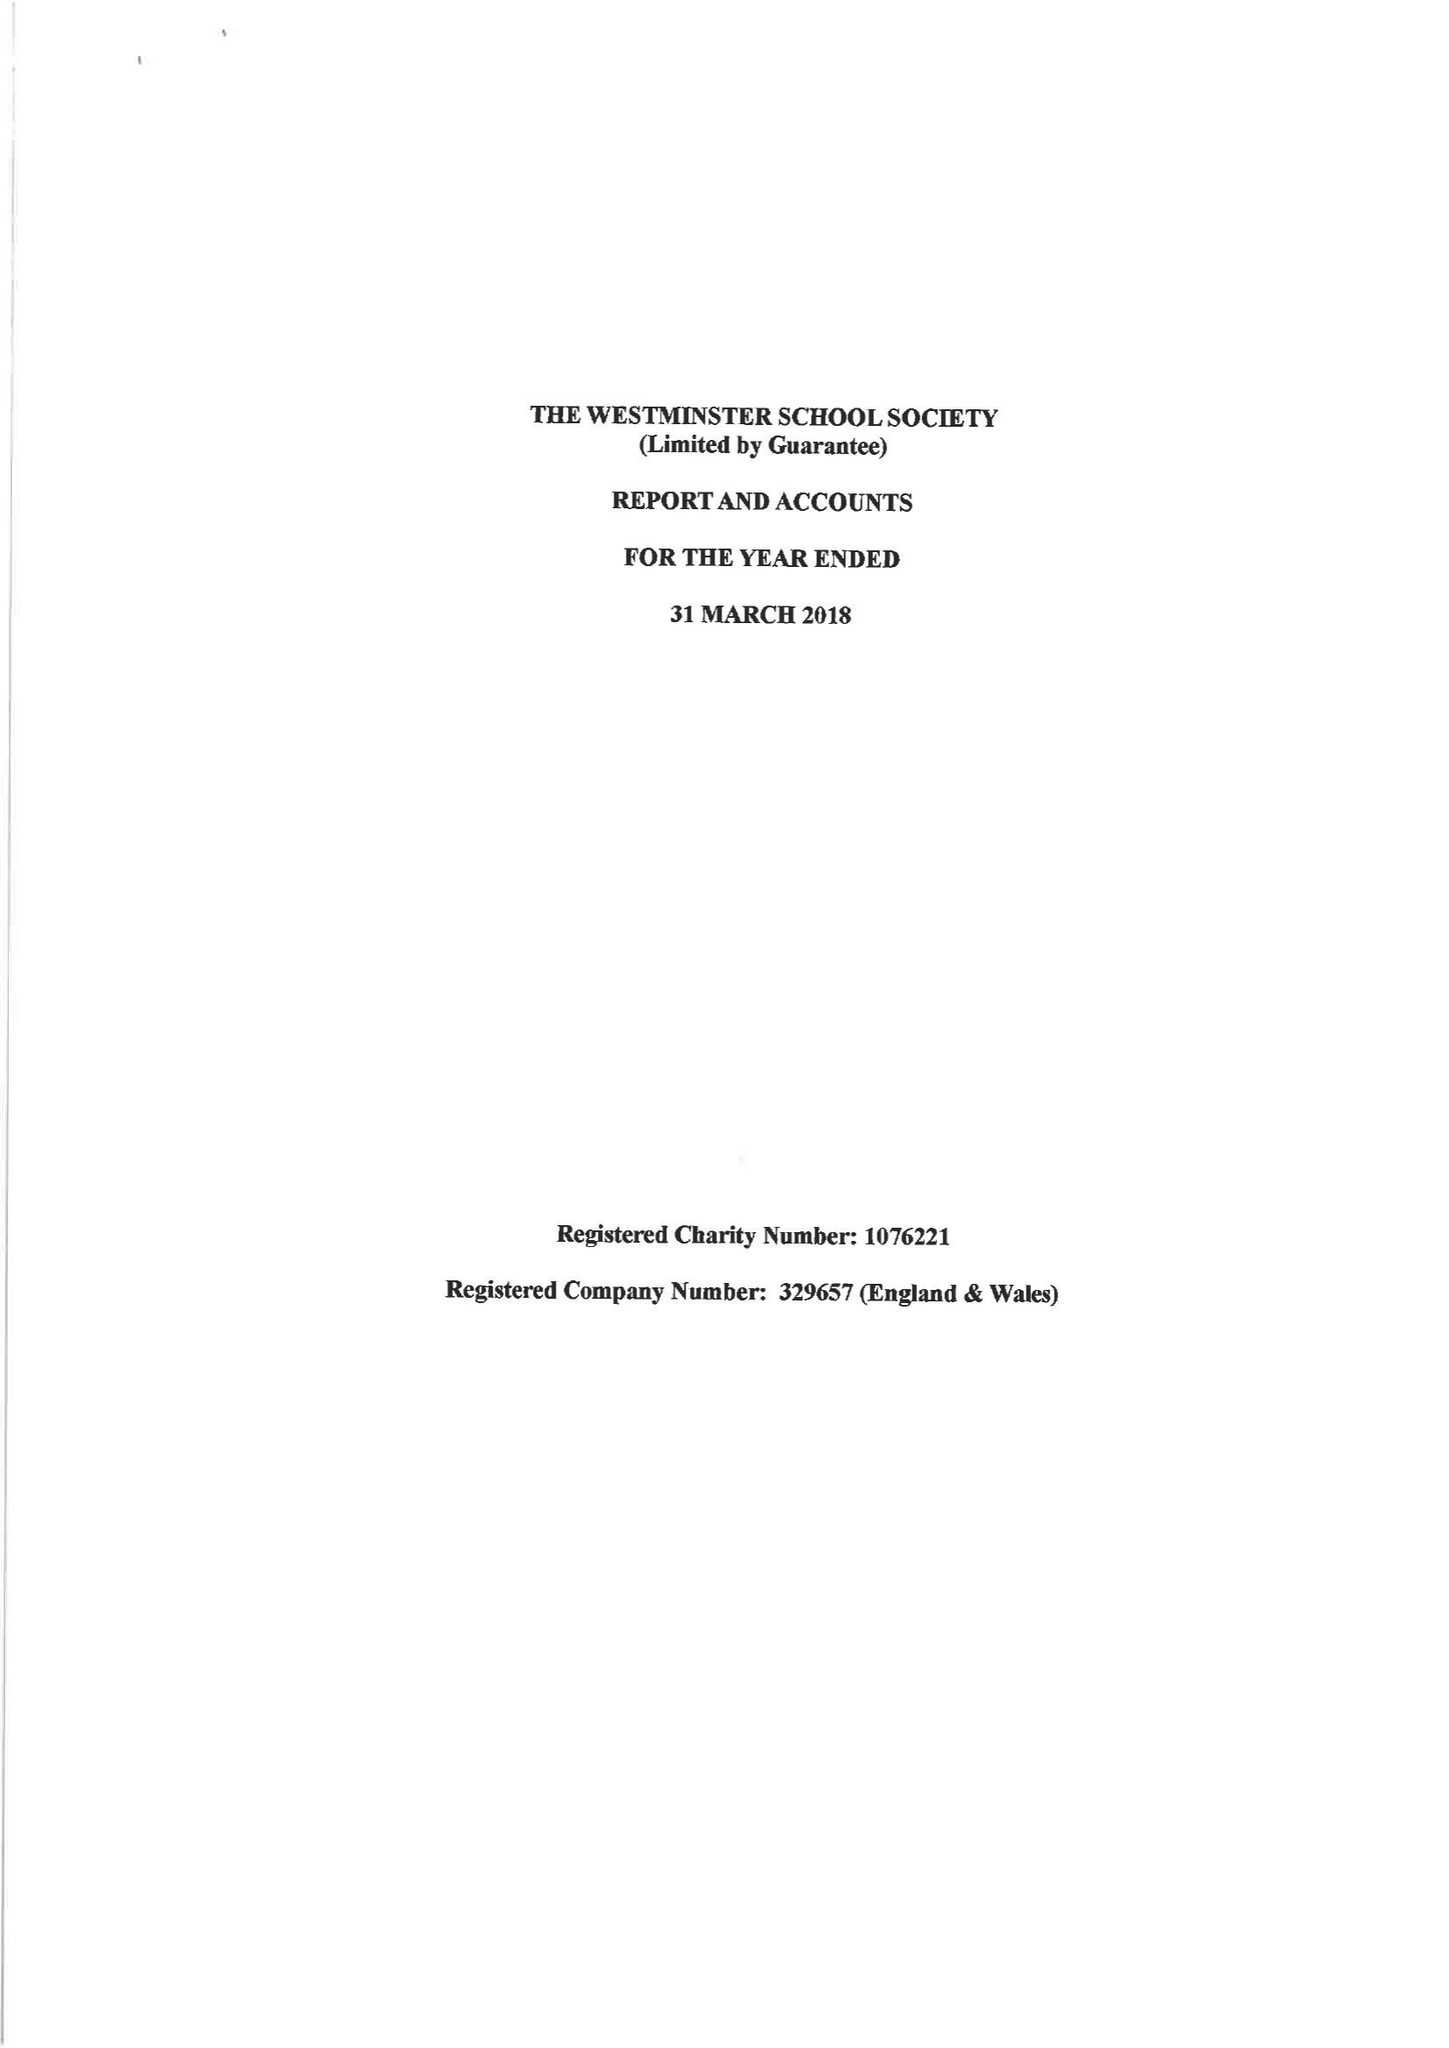What is the value for the address__postcode?
Answer the question using a single word or phrase. SW1P 3PB 